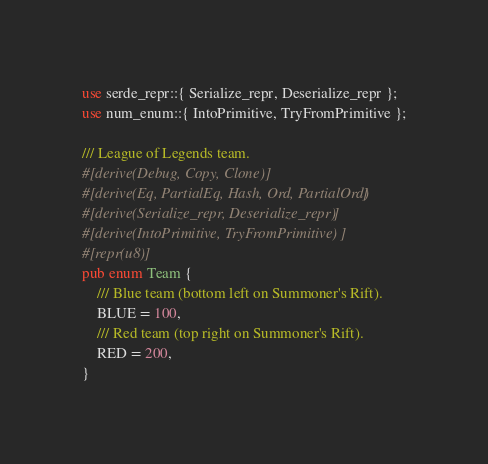<code> <loc_0><loc_0><loc_500><loc_500><_Rust_>use serde_repr::{ Serialize_repr, Deserialize_repr };
use num_enum::{ IntoPrimitive, TryFromPrimitive };

/// League of Legends team.
#[derive(Debug, Copy, Clone)]
#[derive(Eq, PartialEq, Hash, Ord, PartialOrd)]
#[derive(Serialize_repr, Deserialize_repr)]
#[derive(IntoPrimitive, TryFromPrimitive)]
#[repr(u8)]
pub enum Team {
    /// Blue team (bottom left on Summoner's Rift).
    BLUE = 100,
    /// Red team (top right on Summoner's Rift).
    RED = 200,
}
</code> 